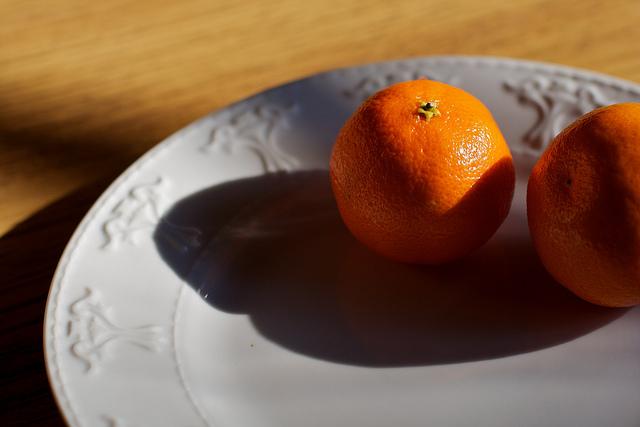What are the oranges on top of?
Be succinct. Plate. How many shadows are being cast in this photo?
Keep it brief. 2. What color is the plate?
Give a very brief answer. White. What are the oranges sitting on?
Give a very brief answer. Plate. 